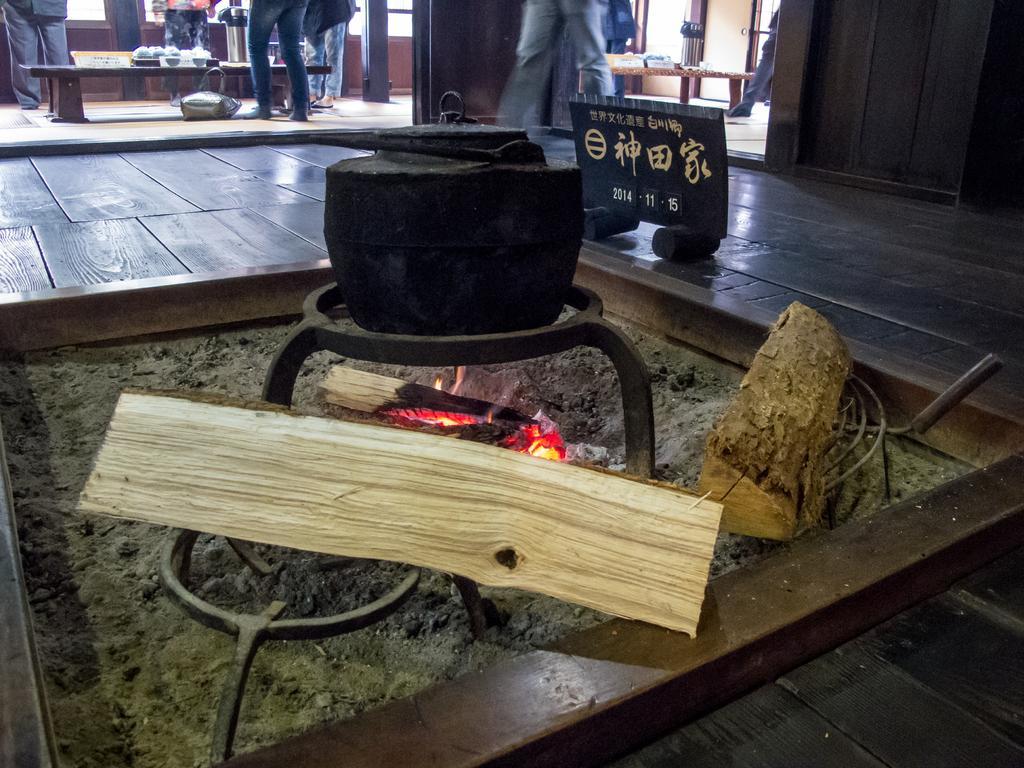Describe this image in one or two sentences. In this image we can see cooking on fire, persons standing on the floor, benches and an information board. 